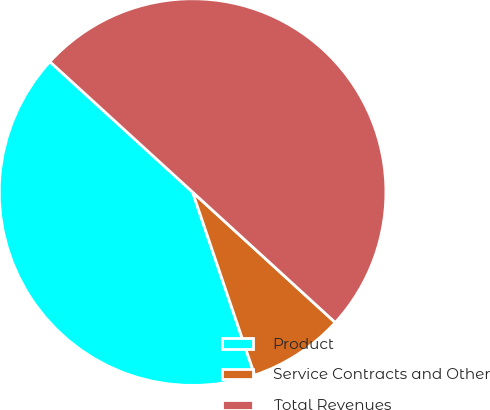Convert chart to OTSL. <chart><loc_0><loc_0><loc_500><loc_500><pie_chart><fcel>Product<fcel>Service Contracts and Other<fcel>Total Revenues<nl><fcel>41.99%<fcel>8.01%<fcel>50.0%<nl></chart> 